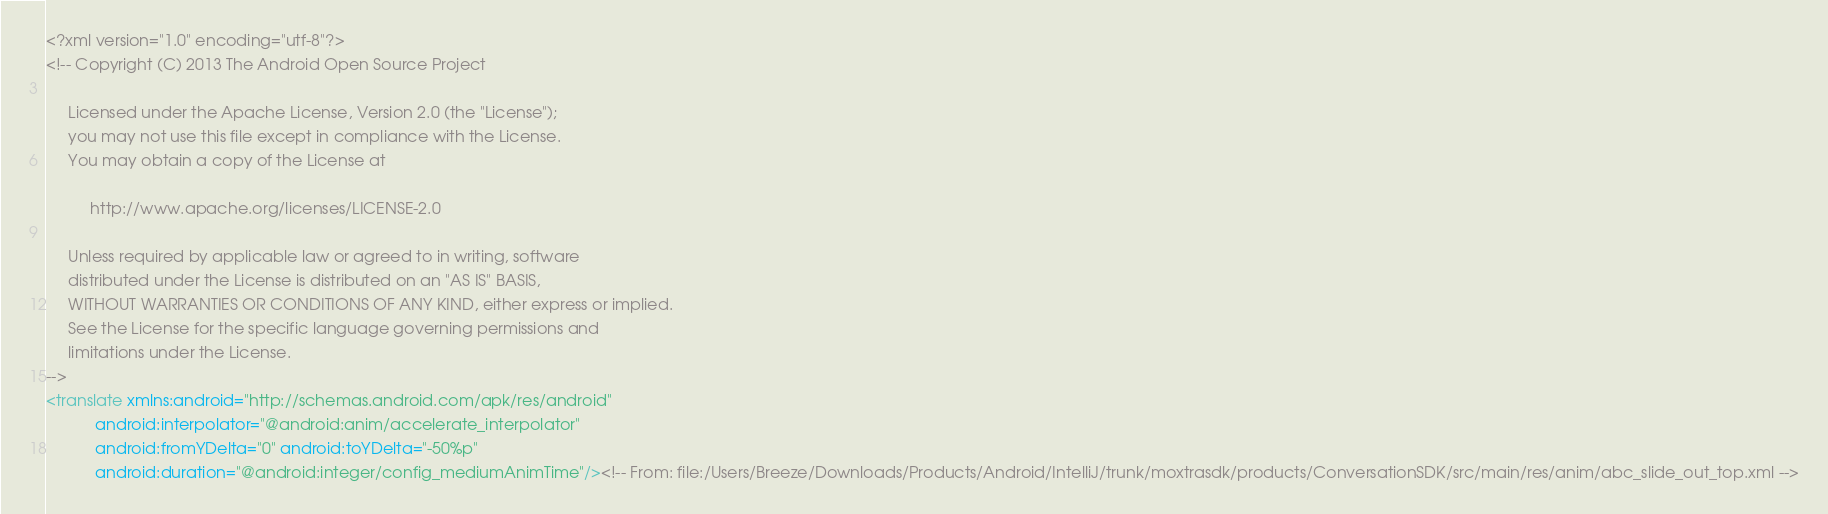Convert code to text. <code><loc_0><loc_0><loc_500><loc_500><_XML_><?xml version="1.0" encoding="utf-8"?>
<!-- Copyright (C) 2013 The Android Open Source Project

     Licensed under the Apache License, Version 2.0 (the "License");
     you may not use this file except in compliance with the License.
     You may obtain a copy of the License at

          http://www.apache.org/licenses/LICENSE-2.0

     Unless required by applicable law or agreed to in writing, software
     distributed under the License is distributed on an "AS IS" BASIS,
     WITHOUT WARRANTIES OR CONDITIONS OF ANY KIND, either express or implied.
     See the License for the specific language governing permissions and
     limitations under the License.
-->
<translate xmlns:android="http://schemas.android.com/apk/res/android"
           android:interpolator="@android:anim/accelerate_interpolator"
           android:fromYDelta="0" android:toYDelta="-50%p"
           android:duration="@android:integer/config_mediumAnimTime"/><!-- From: file:/Users/Breeze/Downloads/Products/Android/IntelliJ/trunk/moxtrasdk/products/ConversationSDK/src/main/res/anim/abc_slide_out_top.xml --></code> 